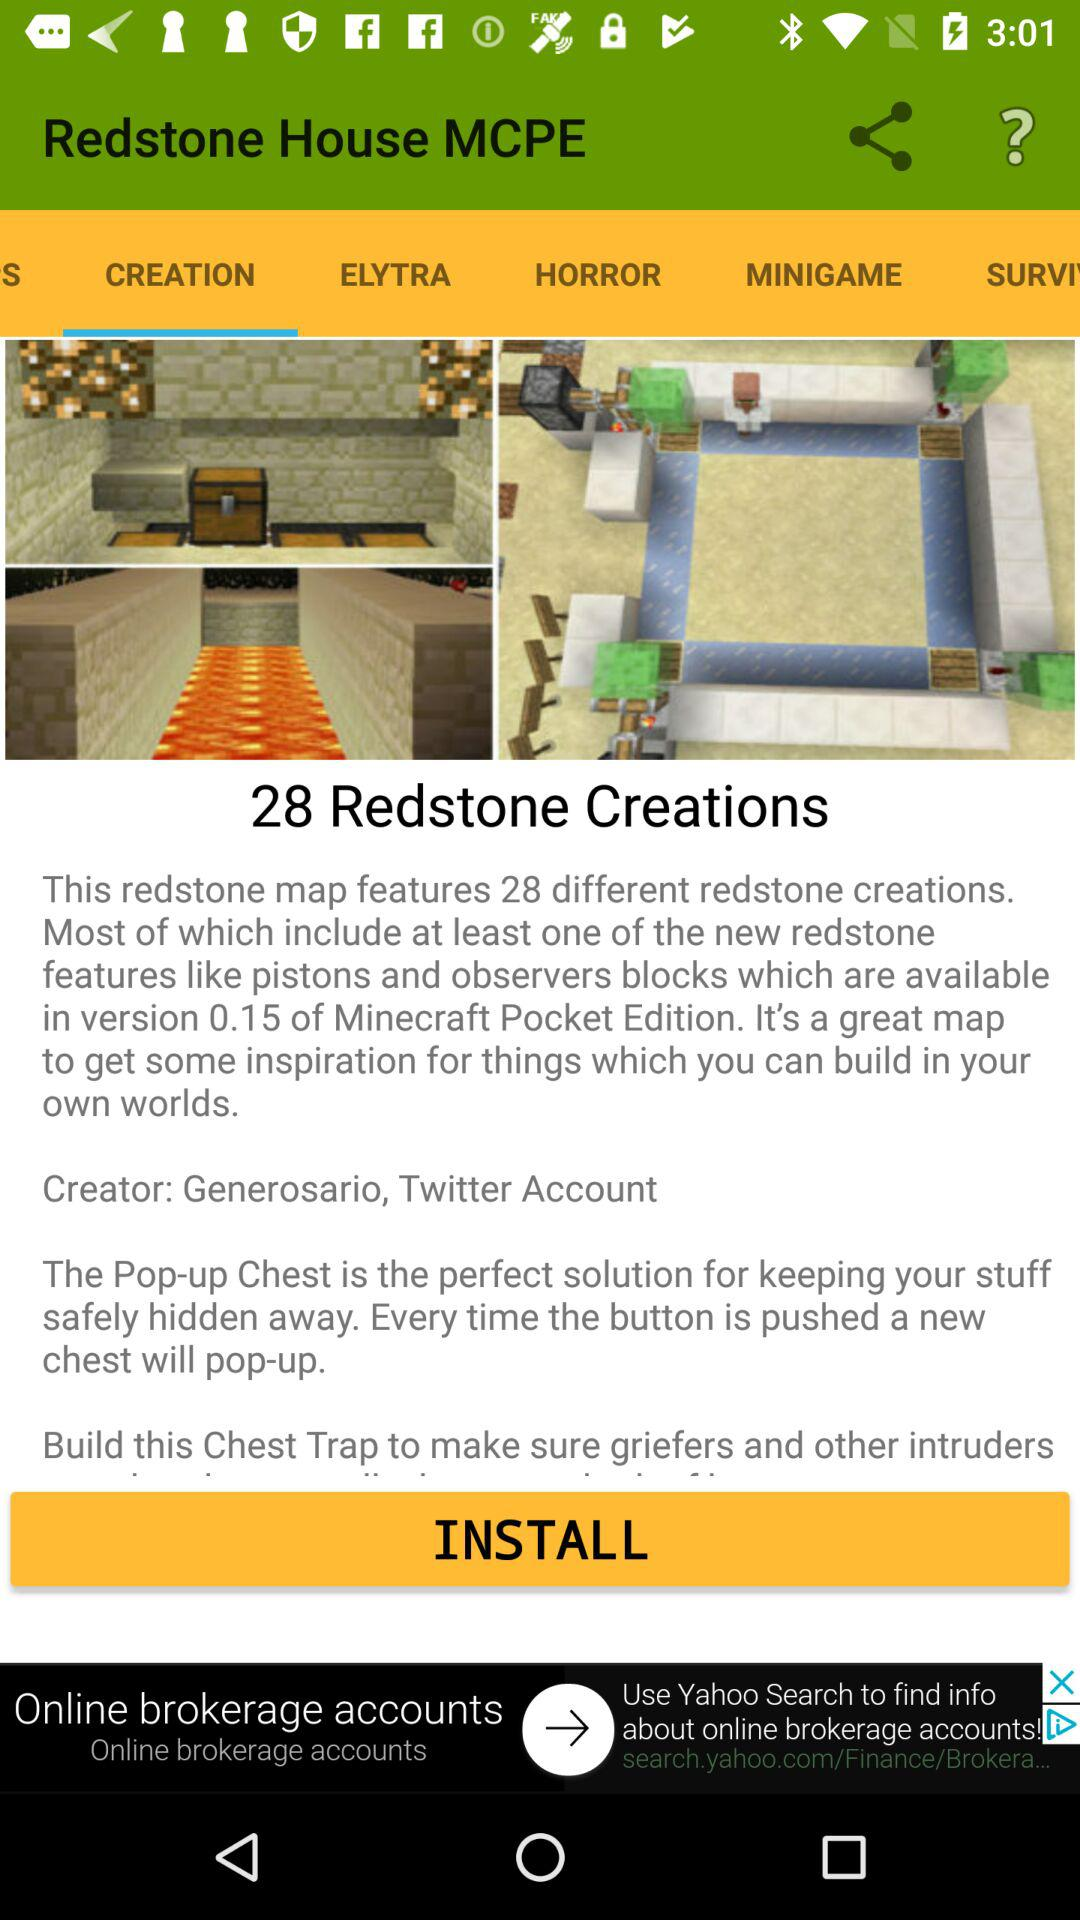What is the name of the creation? The name is "Redstone". 